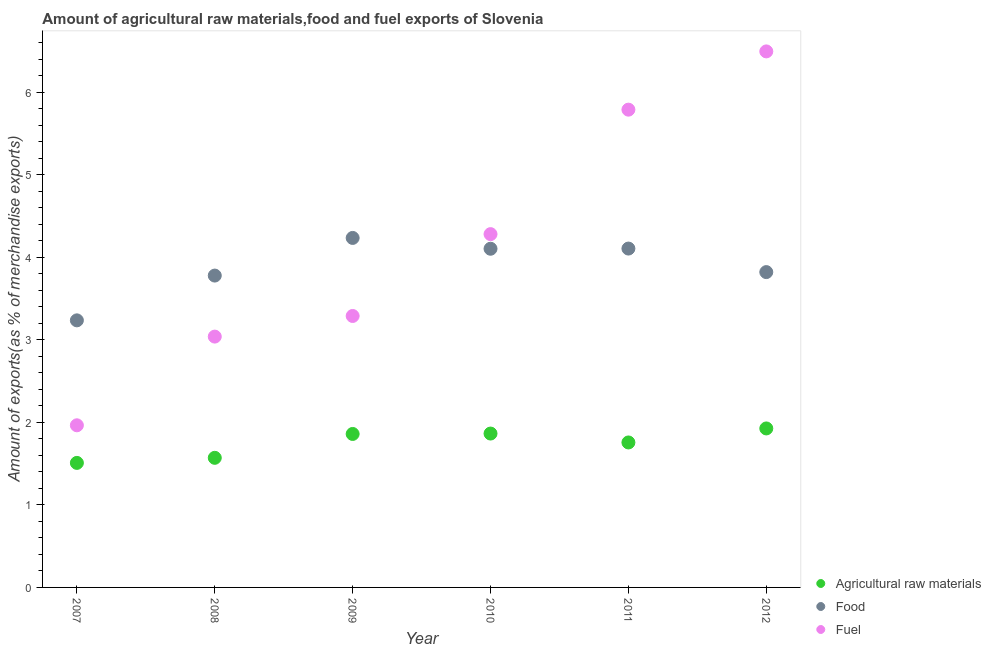What is the percentage of raw materials exports in 2010?
Ensure brevity in your answer.  1.87. Across all years, what is the maximum percentage of fuel exports?
Provide a short and direct response. 6.5. Across all years, what is the minimum percentage of raw materials exports?
Ensure brevity in your answer.  1.51. In which year was the percentage of fuel exports maximum?
Ensure brevity in your answer.  2012. In which year was the percentage of food exports minimum?
Your response must be concise. 2007. What is the total percentage of fuel exports in the graph?
Give a very brief answer. 24.87. What is the difference between the percentage of raw materials exports in 2009 and that in 2012?
Keep it short and to the point. -0.07. What is the difference between the percentage of raw materials exports in 2007 and the percentage of fuel exports in 2010?
Keep it short and to the point. -2.77. What is the average percentage of fuel exports per year?
Provide a succinct answer. 4.14. In the year 2007, what is the difference between the percentage of food exports and percentage of fuel exports?
Your response must be concise. 1.27. In how many years, is the percentage of fuel exports greater than 3.4 %?
Make the answer very short. 3. What is the ratio of the percentage of raw materials exports in 2009 to that in 2012?
Make the answer very short. 0.97. Is the difference between the percentage of fuel exports in 2009 and 2010 greater than the difference between the percentage of raw materials exports in 2009 and 2010?
Provide a succinct answer. No. What is the difference between the highest and the second highest percentage of fuel exports?
Keep it short and to the point. 0.71. What is the difference between the highest and the lowest percentage of food exports?
Give a very brief answer. 1. In how many years, is the percentage of food exports greater than the average percentage of food exports taken over all years?
Your response must be concise. 3. Is the sum of the percentage of raw materials exports in 2007 and 2011 greater than the maximum percentage of fuel exports across all years?
Provide a short and direct response. No. Does the percentage of food exports monotonically increase over the years?
Ensure brevity in your answer.  No. Is the percentage of food exports strictly less than the percentage of fuel exports over the years?
Your answer should be very brief. No. Does the graph contain any zero values?
Ensure brevity in your answer.  No. Does the graph contain grids?
Ensure brevity in your answer.  No. How many legend labels are there?
Your response must be concise. 3. What is the title of the graph?
Your response must be concise. Amount of agricultural raw materials,food and fuel exports of Slovenia. What is the label or title of the X-axis?
Your answer should be very brief. Year. What is the label or title of the Y-axis?
Your response must be concise. Amount of exports(as % of merchandise exports). What is the Amount of exports(as % of merchandise exports) of Agricultural raw materials in 2007?
Make the answer very short. 1.51. What is the Amount of exports(as % of merchandise exports) of Food in 2007?
Provide a short and direct response. 3.24. What is the Amount of exports(as % of merchandise exports) in Fuel in 2007?
Provide a succinct answer. 1.97. What is the Amount of exports(as % of merchandise exports) in Agricultural raw materials in 2008?
Your answer should be compact. 1.57. What is the Amount of exports(as % of merchandise exports) of Food in 2008?
Keep it short and to the point. 3.78. What is the Amount of exports(as % of merchandise exports) of Fuel in 2008?
Keep it short and to the point. 3.04. What is the Amount of exports(as % of merchandise exports) of Agricultural raw materials in 2009?
Your answer should be compact. 1.86. What is the Amount of exports(as % of merchandise exports) in Food in 2009?
Offer a very short reply. 4.24. What is the Amount of exports(as % of merchandise exports) in Fuel in 2009?
Make the answer very short. 3.29. What is the Amount of exports(as % of merchandise exports) of Agricultural raw materials in 2010?
Provide a succinct answer. 1.87. What is the Amount of exports(as % of merchandise exports) in Food in 2010?
Offer a very short reply. 4.11. What is the Amount of exports(as % of merchandise exports) of Fuel in 2010?
Keep it short and to the point. 4.28. What is the Amount of exports(as % of merchandise exports) of Agricultural raw materials in 2011?
Your answer should be very brief. 1.76. What is the Amount of exports(as % of merchandise exports) in Food in 2011?
Give a very brief answer. 4.11. What is the Amount of exports(as % of merchandise exports) of Fuel in 2011?
Give a very brief answer. 5.79. What is the Amount of exports(as % of merchandise exports) in Agricultural raw materials in 2012?
Your answer should be compact. 1.93. What is the Amount of exports(as % of merchandise exports) of Food in 2012?
Offer a terse response. 3.82. What is the Amount of exports(as % of merchandise exports) of Fuel in 2012?
Make the answer very short. 6.5. Across all years, what is the maximum Amount of exports(as % of merchandise exports) in Agricultural raw materials?
Your answer should be compact. 1.93. Across all years, what is the maximum Amount of exports(as % of merchandise exports) of Food?
Provide a short and direct response. 4.24. Across all years, what is the maximum Amount of exports(as % of merchandise exports) of Fuel?
Provide a succinct answer. 6.5. Across all years, what is the minimum Amount of exports(as % of merchandise exports) in Agricultural raw materials?
Give a very brief answer. 1.51. Across all years, what is the minimum Amount of exports(as % of merchandise exports) in Food?
Ensure brevity in your answer.  3.24. Across all years, what is the minimum Amount of exports(as % of merchandise exports) in Fuel?
Offer a terse response. 1.97. What is the total Amount of exports(as % of merchandise exports) of Agricultural raw materials in the graph?
Give a very brief answer. 10.49. What is the total Amount of exports(as % of merchandise exports) in Food in the graph?
Ensure brevity in your answer.  23.29. What is the total Amount of exports(as % of merchandise exports) in Fuel in the graph?
Ensure brevity in your answer.  24.87. What is the difference between the Amount of exports(as % of merchandise exports) in Agricultural raw materials in 2007 and that in 2008?
Your response must be concise. -0.06. What is the difference between the Amount of exports(as % of merchandise exports) of Food in 2007 and that in 2008?
Your answer should be compact. -0.54. What is the difference between the Amount of exports(as % of merchandise exports) in Fuel in 2007 and that in 2008?
Make the answer very short. -1.08. What is the difference between the Amount of exports(as % of merchandise exports) in Agricultural raw materials in 2007 and that in 2009?
Offer a terse response. -0.35. What is the difference between the Amount of exports(as % of merchandise exports) of Food in 2007 and that in 2009?
Make the answer very short. -1. What is the difference between the Amount of exports(as % of merchandise exports) in Fuel in 2007 and that in 2009?
Give a very brief answer. -1.33. What is the difference between the Amount of exports(as % of merchandise exports) of Agricultural raw materials in 2007 and that in 2010?
Offer a terse response. -0.36. What is the difference between the Amount of exports(as % of merchandise exports) of Food in 2007 and that in 2010?
Give a very brief answer. -0.87. What is the difference between the Amount of exports(as % of merchandise exports) of Fuel in 2007 and that in 2010?
Your response must be concise. -2.32. What is the difference between the Amount of exports(as % of merchandise exports) in Agricultural raw materials in 2007 and that in 2011?
Make the answer very short. -0.25. What is the difference between the Amount of exports(as % of merchandise exports) in Food in 2007 and that in 2011?
Provide a succinct answer. -0.87. What is the difference between the Amount of exports(as % of merchandise exports) in Fuel in 2007 and that in 2011?
Offer a terse response. -3.83. What is the difference between the Amount of exports(as % of merchandise exports) of Agricultural raw materials in 2007 and that in 2012?
Make the answer very short. -0.42. What is the difference between the Amount of exports(as % of merchandise exports) of Food in 2007 and that in 2012?
Ensure brevity in your answer.  -0.58. What is the difference between the Amount of exports(as % of merchandise exports) in Fuel in 2007 and that in 2012?
Offer a very short reply. -4.53. What is the difference between the Amount of exports(as % of merchandise exports) of Agricultural raw materials in 2008 and that in 2009?
Provide a succinct answer. -0.29. What is the difference between the Amount of exports(as % of merchandise exports) in Food in 2008 and that in 2009?
Provide a short and direct response. -0.46. What is the difference between the Amount of exports(as % of merchandise exports) of Fuel in 2008 and that in 2009?
Ensure brevity in your answer.  -0.25. What is the difference between the Amount of exports(as % of merchandise exports) in Agricultural raw materials in 2008 and that in 2010?
Give a very brief answer. -0.29. What is the difference between the Amount of exports(as % of merchandise exports) of Food in 2008 and that in 2010?
Offer a very short reply. -0.33. What is the difference between the Amount of exports(as % of merchandise exports) in Fuel in 2008 and that in 2010?
Offer a terse response. -1.24. What is the difference between the Amount of exports(as % of merchandise exports) of Agricultural raw materials in 2008 and that in 2011?
Ensure brevity in your answer.  -0.19. What is the difference between the Amount of exports(as % of merchandise exports) in Food in 2008 and that in 2011?
Your answer should be compact. -0.33. What is the difference between the Amount of exports(as % of merchandise exports) in Fuel in 2008 and that in 2011?
Give a very brief answer. -2.75. What is the difference between the Amount of exports(as % of merchandise exports) in Agricultural raw materials in 2008 and that in 2012?
Your answer should be very brief. -0.36. What is the difference between the Amount of exports(as % of merchandise exports) in Food in 2008 and that in 2012?
Ensure brevity in your answer.  -0.04. What is the difference between the Amount of exports(as % of merchandise exports) in Fuel in 2008 and that in 2012?
Ensure brevity in your answer.  -3.46. What is the difference between the Amount of exports(as % of merchandise exports) in Agricultural raw materials in 2009 and that in 2010?
Ensure brevity in your answer.  -0. What is the difference between the Amount of exports(as % of merchandise exports) in Food in 2009 and that in 2010?
Your answer should be compact. 0.13. What is the difference between the Amount of exports(as % of merchandise exports) of Fuel in 2009 and that in 2010?
Give a very brief answer. -0.99. What is the difference between the Amount of exports(as % of merchandise exports) of Agricultural raw materials in 2009 and that in 2011?
Make the answer very short. 0.1. What is the difference between the Amount of exports(as % of merchandise exports) in Food in 2009 and that in 2011?
Your response must be concise. 0.13. What is the difference between the Amount of exports(as % of merchandise exports) of Fuel in 2009 and that in 2011?
Your answer should be very brief. -2.5. What is the difference between the Amount of exports(as % of merchandise exports) in Agricultural raw materials in 2009 and that in 2012?
Ensure brevity in your answer.  -0.07. What is the difference between the Amount of exports(as % of merchandise exports) in Food in 2009 and that in 2012?
Ensure brevity in your answer.  0.41. What is the difference between the Amount of exports(as % of merchandise exports) of Fuel in 2009 and that in 2012?
Provide a succinct answer. -3.21. What is the difference between the Amount of exports(as % of merchandise exports) in Agricultural raw materials in 2010 and that in 2011?
Give a very brief answer. 0.11. What is the difference between the Amount of exports(as % of merchandise exports) in Food in 2010 and that in 2011?
Ensure brevity in your answer.  -0. What is the difference between the Amount of exports(as % of merchandise exports) in Fuel in 2010 and that in 2011?
Provide a succinct answer. -1.51. What is the difference between the Amount of exports(as % of merchandise exports) in Agricultural raw materials in 2010 and that in 2012?
Keep it short and to the point. -0.06. What is the difference between the Amount of exports(as % of merchandise exports) in Food in 2010 and that in 2012?
Give a very brief answer. 0.28. What is the difference between the Amount of exports(as % of merchandise exports) of Fuel in 2010 and that in 2012?
Your response must be concise. -2.21. What is the difference between the Amount of exports(as % of merchandise exports) of Agricultural raw materials in 2011 and that in 2012?
Your response must be concise. -0.17. What is the difference between the Amount of exports(as % of merchandise exports) of Food in 2011 and that in 2012?
Your response must be concise. 0.29. What is the difference between the Amount of exports(as % of merchandise exports) of Fuel in 2011 and that in 2012?
Make the answer very short. -0.71. What is the difference between the Amount of exports(as % of merchandise exports) in Agricultural raw materials in 2007 and the Amount of exports(as % of merchandise exports) in Food in 2008?
Your answer should be compact. -2.27. What is the difference between the Amount of exports(as % of merchandise exports) of Agricultural raw materials in 2007 and the Amount of exports(as % of merchandise exports) of Fuel in 2008?
Offer a very short reply. -1.53. What is the difference between the Amount of exports(as % of merchandise exports) of Food in 2007 and the Amount of exports(as % of merchandise exports) of Fuel in 2008?
Keep it short and to the point. 0.2. What is the difference between the Amount of exports(as % of merchandise exports) of Agricultural raw materials in 2007 and the Amount of exports(as % of merchandise exports) of Food in 2009?
Provide a succinct answer. -2.73. What is the difference between the Amount of exports(as % of merchandise exports) in Agricultural raw materials in 2007 and the Amount of exports(as % of merchandise exports) in Fuel in 2009?
Make the answer very short. -1.78. What is the difference between the Amount of exports(as % of merchandise exports) in Food in 2007 and the Amount of exports(as % of merchandise exports) in Fuel in 2009?
Give a very brief answer. -0.05. What is the difference between the Amount of exports(as % of merchandise exports) in Agricultural raw materials in 2007 and the Amount of exports(as % of merchandise exports) in Food in 2010?
Provide a short and direct response. -2.6. What is the difference between the Amount of exports(as % of merchandise exports) in Agricultural raw materials in 2007 and the Amount of exports(as % of merchandise exports) in Fuel in 2010?
Keep it short and to the point. -2.77. What is the difference between the Amount of exports(as % of merchandise exports) of Food in 2007 and the Amount of exports(as % of merchandise exports) of Fuel in 2010?
Provide a succinct answer. -1.05. What is the difference between the Amount of exports(as % of merchandise exports) in Agricultural raw materials in 2007 and the Amount of exports(as % of merchandise exports) in Food in 2011?
Your answer should be very brief. -2.6. What is the difference between the Amount of exports(as % of merchandise exports) in Agricultural raw materials in 2007 and the Amount of exports(as % of merchandise exports) in Fuel in 2011?
Your answer should be compact. -4.28. What is the difference between the Amount of exports(as % of merchandise exports) of Food in 2007 and the Amount of exports(as % of merchandise exports) of Fuel in 2011?
Your answer should be very brief. -2.55. What is the difference between the Amount of exports(as % of merchandise exports) in Agricultural raw materials in 2007 and the Amount of exports(as % of merchandise exports) in Food in 2012?
Keep it short and to the point. -2.31. What is the difference between the Amount of exports(as % of merchandise exports) of Agricultural raw materials in 2007 and the Amount of exports(as % of merchandise exports) of Fuel in 2012?
Offer a terse response. -4.99. What is the difference between the Amount of exports(as % of merchandise exports) of Food in 2007 and the Amount of exports(as % of merchandise exports) of Fuel in 2012?
Your answer should be compact. -3.26. What is the difference between the Amount of exports(as % of merchandise exports) of Agricultural raw materials in 2008 and the Amount of exports(as % of merchandise exports) of Food in 2009?
Make the answer very short. -2.67. What is the difference between the Amount of exports(as % of merchandise exports) of Agricultural raw materials in 2008 and the Amount of exports(as % of merchandise exports) of Fuel in 2009?
Ensure brevity in your answer.  -1.72. What is the difference between the Amount of exports(as % of merchandise exports) of Food in 2008 and the Amount of exports(as % of merchandise exports) of Fuel in 2009?
Your response must be concise. 0.49. What is the difference between the Amount of exports(as % of merchandise exports) of Agricultural raw materials in 2008 and the Amount of exports(as % of merchandise exports) of Food in 2010?
Offer a terse response. -2.53. What is the difference between the Amount of exports(as % of merchandise exports) in Agricultural raw materials in 2008 and the Amount of exports(as % of merchandise exports) in Fuel in 2010?
Your response must be concise. -2.71. What is the difference between the Amount of exports(as % of merchandise exports) of Food in 2008 and the Amount of exports(as % of merchandise exports) of Fuel in 2010?
Make the answer very short. -0.5. What is the difference between the Amount of exports(as % of merchandise exports) in Agricultural raw materials in 2008 and the Amount of exports(as % of merchandise exports) in Food in 2011?
Your answer should be very brief. -2.54. What is the difference between the Amount of exports(as % of merchandise exports) in Agricultural raw materials in 2008 and the Amount of exports(as % of merchandise exports) in Fuel in 2011?
Offer a terse response. -4.22. What is the difference between the Amount of exports(as % of merchandise exports) of Food in 2008 and the Amount of exports(as % of merchandise exports) of Fuel in 2011?
Give a very brief answer. -2.01. What is the difference between the Amount of exports(as % of merchandise exports) in Agricultural raw materials in 2008 and the Amount of exports(as % of merchandise exports) in Food in 2012?
Give a very brief answer. -2.25. What is the difference between the Amount of exports(as % of merchandise exports) of Agricultural raw materials in 2008 and the Amount of exports(as % of merchandise exports) of Fuel in 2012?
Your response must be concise. -4.93. What is the difference between the Amount of exports(as % of merchandise exports) of Food in 2008 and the Amount of exports(as % of merchandise exports) of Fuel in 2012?
Keep it short and to the point. -2.72. What is the difference between the Amount of exports(as % of merchandise exports) of Agricultural raw materials in 2009 and the Amount of exports(as % of merchandise exports) of Food in 2010?
Provide a short and direct response. -2.25. What is the difference between the Amount of exports(as % of merchandise exports) in Agricultural raw materials in 2009 and the Amount of exports(as % of merchandise exports) in Fuel in 2010?
Your answer should be compact. -2.42. What is the difference between the Amount of exports(as % of merchandise exports) of Food in 2009 and the Amount of exports(as % of merchandise exports) of Fuel in 2010?
Give a very brief answer. -0.05. What is the difference between the Amount of exports(as % of merchandise exports) of Agricultural raw materials in 2009 and the Amount of exports(as % of merchandise exports) of Food in 2011?
Your answer should be compact. -2.25. What is the difference between the Amount of exports(as % of merchandise exports) in Agricultural raw materials in 2009 and the Amount of exports(as % of merchandise exports) in Fuel in 2011?
Give a very brief answer. -3.93. What is the difference between the Amount of exports(as % of merchandise exports) in Food in 2009 and the Amount of exports(as % of merchandise exports) in Fuel in 2011?
Provide a short and direct response. -1.55. What is the difference between the Amount of exports(as % of merchandise exports) of Agricultural raw materials in 2009 and the Amount of exports(as % of merchandise exports) of Food in 2012?
Offer a very short reply. -1.96. What is the difference between the Amount of exports(as % of merchandise exports) of Agricultural raw materials in 2009 and the Amount of exports(as % of merchandise exports) of Fuel in 2012?
Your answer should be compact. -4.64. What is the difference between the Amount of exports(as % of merchandise exports) in Food in 2009 and the Amount of exports(as % of merchandise exports) in Fuel in 2012?
Your response must be concise. -2.26. What is the difference between the Amount of exports(as % of merchandise exports) in Agricultural raw materials in 2010 and the Amount of exports(as % of merchandise exports) in Food in 2011?
Offer a very short reply. -2.24. What is the difference between the Amount of exports(as % of merchandise exports) in Agricultural raw materials in 2010 and the Amount of exports(as % of merchandise exports) in Fuel in 2011?
Keep it short and to the point. -3.93. What is the difference between the Amount of exports(as % of merchandise exports) in Food in 2010 and the Amount of exports(as % of merchandise exports) in Fuel in 2011?
Your response must be concise. -1.69. What is the difference between the Amount of exports(as % of merchandise exports) in Agricultural raw materials in 2010 and the Amount of exports(as % of merchandise exports) in Food in 2012?
Keep it short and to the point. -1.96. What is the difference between the Amount of exports(as % of merchandise exports) of Agricultural raw materials in 2010 and the Amount of exports(as % of merchandise exports) of Fuel in 2012?
Your answer should be very brief. -4.63. What is the difference between the Amount of exports(as % of merchandise exports) of Food in 2010 and the Amount of exports(as % of merchandise exports) of Fuel in 2012?
Ensure brevity in your answer.  -2.39. What is the difference between the Amount of exports(as % of merchandise exports) in Agricultural raw materials in 2011 and the Amount of exports(as % of merchandise exports) in Food in 2012?
Make the answer very short. -2.06. What is the difference between the Amount of exports(as % of merchandise exports) of Agricultural raw materials in 2011 and the Amount of exports(as % of merchandise exports) of Fuel in 2012?
Your answer should be very brief. -4.74. What is the difference between the Amount of exports(as % of merchandise exports) in Food in 2011 and the Amount of exports(as % of merchandise exports) in Fuel in 2012?
Provide a short and direct response. -2.39. What is the average Amount of exports(as % of merchandise exports) of Agricultural raw materials per year?
Provide a short and direct response. 1.75. What is the average Amount of exports(as % of merchandise exports) of Food per year?
Offer a very short reply. 3.88. What is the average Amount of exports(as % of merchandise exports) of Fuel per year?
Your response must be concise. 4.14. In the year 2007, what is the difference between the Amount of exports(as % of merchandise exports) of Agricultural raw materials and Amount of exports(as % of merchandise exports) of Food?
Keep it short and to the point. -1.73. In the year 2007, what is the difference between the Amount of exports(as % of merchandise exports) of Agricultural raw materials and Amount of exports(as % of merchandise exports) of Fuel?
Keep it short and to the point. -0.46. In the year 2007, what is the difference between the Amount of exports(as % of merchandise exports) of Food and Amount of exports(as % of merchandise exports) of Fuel?
Offer a terse response. 1.27. In the year 2008, what is the difference between the Amount of exports(as % of merchandise exports) of Agricultural raw materials and Amount of exports(as % of merchandise exports) of Food?
Ensure brevity in your answer.  -2.21. In the year 2008, what is the difference between the Amount of exports(as % of merchandise exports) in Agricultural raw materials and Amount of exports(as % of merchandise exports) in Fuel?
Provide a succinct answer. -1.47. In the year 2008, what is the difference between the Amount of exports(as % of merchandise exports) of Food and Amount of exports(as % of merchandise exports) of Fuel?
Give a very brief answer. 0.74. In the year 2009, what is the difference between the Amount of exports(as % of merchandise exports) of Agricultural raw materials and Amount of exports(as % of merchandise exports) of Food?
Ensure brevity in your answer.  -2.38. In the year 2009, what is the difference between the Amount of exports(as % of merchandise exports) in Agricultural raw materials and Amount of exports(as % of merchandise exports) in Fuel?
Offer a terse response. -1.43. In the year 2009, what is the difference between the Amount of exports(as % of merchandise exports) of Food and Amount of exports(as % of merchandise exports) of Fuel?
Offer a terse response. 0.95. In the year 2010, what is the difference between the Amount of exports(as % of merchandise exports) in Agricultural raw materials and Amount of exports(as % of merchandise exports) in Food?
Ensure brevity in your answer.  -2.24. In the year 2010, what is the difference between the Amount of exports(as % of merchandise exports) in Agricultural raw materials and Amount of exports(as % of merchandise exports) in Fuel?
Your answer should be compact. -2.42. In the year 2010, what is the difference between the Amount of exports(as % of merchandise exports) of Food and Amount of exports(as % of merchandise exports) of Fuel?
Make the answer very short. -0.18. In the year 2011, what is the difference between the Amount of exports(as % of merchandise exports) of Agricultural raw materials and Amount of exports(as % of merchandise exports) of Food?
Keep it short and to the point. -2.35. In the year 2011, what is the difference between the Amount of exports(as % of merchandise exports) in Agricultural raw materials and Amount of exports(as % of merchandise exports) in Fuel?
Provide a short and direct response. -4.03. In the year 2011, what is the difference between the Amount of exports(as % of merchandise exports) of Food and Amount of exports(as % of merchandise exports) of Fuel?
Make the answer very short. -1.68. In the year 2012, what is the difference between the Amount of exports(as % of merchandise exports) of Agricultural raw materials and Amount of exports(as % of merchandise exports) of Food?
Give a very brief answer. -1.9. In the year 2012, what is the difference between the Amount of exports(as % of merchandise exports) in Agricultural raw materials and Amount of exports(as % of merchandise exports) in Fuel?
Your answer should be very brief. -4.57. In the year 2012, what is the difference between the Amount of exports(as % of merchandise exports) in Food and Amount of exports(as % of merchandise exports) in Fuel?
Your answer should be very brief. -2.68. What is the ratio of the Amount of exports(as % of merchandise exports) in Agricultural raw materials in 2007 to that in 2008?
Offer a terse response. 0.96. What is the ratio of the Amount of exports(as % of merchandise exports) in Food in 2007 to that in 2008?
Provide a succinct answer. 0.86. What is the ratio of the Amount of exports(as % of merchandise exports) in Fuel in 2007 to that in 2008?
Provide a succinct answer. 0.65. What is the ratio of the Amount of exports(as % of merchandise exports) in Agricultural raw materials in 2007 to that in 2009?
Make the answer very short. 0.81. What is the ratio of the Amount of exports(as % of merchandise exports) of Food in 2007 to that in 2009?
Provide a short and direct response. 0.76. What is the ratio of the Amount of exports(as % of merchandise exports) of Fuel in 2007 to that in 2009?
Your answer should be very brief. 0.6. What is the ratio of the Amount of exports(as % of merchandise exports) in Agricultural raw materials in 2007 to that in 2010?
Ensure brevity in your answer.  0.81. What is the ratio of the Amount of exports(as % of merchandise exports) of Food in 2007 to that in 2010?
Ensure brevity in your answer.  0.79. What is the ratio of the Amount of exports(as % of merchandise exports) in Fuel in 2007 to that in 2010?
Give a very brief answer. 0.46. What is the ratio of the Amount of exports(as % of merchandise exports) in Agricultural raw materials in 2007 to that in 2011?
Your response must be concise. 0.86. What is the ratio of the Amount of exports(as % of merchandise exports) in Food in 2007 to that in 2011?
Provide a short and direct response. 0.79. What is the ratio of the Amount of exports(as % of merchandise exports) of Fuel in 2007 to that in 2011?
Offer a very short reply. 0.34. What is the ratio of the Amount of exports(as % of merchandise exports) in Agricultural raw materials in 2007 to that in 2012?
Your answer should be compact. 0.78. What is the ratio of the Amount of exports(as % of merchandise exports) in Food in 2007 to that in 2012?
Ensure brevity in your answer.  0.85. What is the ratio of the Amount of exports(as % of merchandise exports) of Fuel in 2007 to that in 2012?
Ensure brevity in your answer.  0.3. What is the ratio of the Amount of exports(as % of merchandise exports) in Agricultural raw materials in 2008 to that in 2009?
Ensure brevity in your answer.  0.84. What is the ratio of the Amount of exports(as % of merchandise exports) in Food in 2008 to that in 2009?
Give a very brief answer. 0.89. What is the ratio of the Amount of exports(as % of merchandise exports) in Fuel in 2008 to that in 2009?
Make the answer very short. 0.92. What is the ratio of the Amount of exports(as % of merchandise exports) in Agricultural raw materials in 2008 to that in 2010?
Your answer should be compact. 0.84. What is the ratio of the Amount of exports(as % of merchandise exports) of Food in 2008 to that in 2010?
Provide a short and direct response. 0.92. What is the ratio of the Amount of exports(as % of merchandise exports) of Fuel in 2008 to that in 2010?
Give a very brief answer. 0.71. What is the ratio of the Amount of exports(as % of merchandise exports) of Agricultural raw materials in 2008 to that in 2011?
Provide a short and direct response. 0.89. What is the ratio of the Amount of exports(as % of merchandise exports) in Food in 2008 to that in 2011?
Ensure brevity in your answer.  0.92. What is the ratio of the Amount of exports(as % of merchandise exports) of Fuel in 2008 to that in 2011?
Provide a short and direct response. 0.53. What is the ratio of the Amount of exports(as % of merchandise exports) in Agricultural raw materials in 2008 to that in 2012?
Provide a succinct answer. 0.82. What is the ratio of the Amount of exports(as % of merchandise exports) in Fuel in 2008 to that in 2012?
Provide a succinct answer. 0.47. What is the ratio of the Amount of exports(as % of merchandise exports) in Food in 2009 to that in 2010?
Offer a terse response. 1.03. What is the ratio of the Amount of exports(as % of merchandise exports) in Fuel in 2009 to that in 2010?
Your answer should be very brief. 0.77. What is the ratio of the Amount of exports(as % of merchandise exports) of Agricultural raw materials in 2009 to that in 2011?
Offer a very short reply. 1.06. What is the ratio of the Amount of exports(as % of merchandise exports) of Food in 2009 to that in 2011?
Offer a terse response. 1.03. What is the ratio of the Amount of exports(as % of merchandise exports) in Fuel in 2009 to that in 2011?
Give a very brief answer. 0.57. What is the ratio of the Amount of exports(as % of merchandise exports) of Agricultural raw materials in 2009 to that in 2012?
Offer a terse response. 0.97. What is the ratio of the Amount of exports(as % of merchandise exports) in Food in 2009 to that in 2012?
Your answer should be compact. 1.11. What is the ratio of the Amount of exports(as % of merchandise exports) in Fuel in 2009 to that in 2012?
Ensure brevity in your answer.  0.51. What is the ratio of the Amount of exports(as % of merchandise exports) in Agricultural raw materials in 2010 to that in 2011?
Offer a terse response. 1.06. What is the ratio of the Amount of exports(as % of merchandise exports) in Fuel in 2010 to that in 2011?
Offer a very short reply. 0.74. What is the ratio of the Amount of exports(as % of merchandise exports) of Agricultural raw materials in 2010 to that in 2012?
Ensure brevity in your answer.  0.97. What is the ratio of the Amount of exports(as % of merchandise exports) in Food in 2010 to that in 2012?
Keep it short and to the point. 1.07. What is the ratio of the Amount of exports(as % of merchandise exports) of Fuel in 2010 to that in 2012?
Your answer should be compact. 0.66. What is the ratio of the Amount of exports(as % of merchandise exports) in Agricultural raw materials in 2011 to that in 2012?
Your answer should be very brief. 0.91. What is the ratio of the Amount of exports(as % of merchandise exports) of Food in 2011 to that in 2012?
Make the answer very short. 1.07. What is the ratio of the Amount of exports(as % of merchandise exports) of Fuel in 2011 to that in 2012?
Provide a succinct answer. 0.89. What is the difference between the highest and the second highest Amount of exports(as % of merchandise exports) in Agricultural raw materials?
Keep it short and to the point. 0.06. What is the difference between the highest and the second highest Amount of exports(as % of merchandise exports) in Food?
Your answer should be compact. 0.13. What is the difference between the highest and the second highest Amount of exports(as % of merchandise exports) in Fuel?
Your answer should be very brief. 0.71. What is the difference between the highest and the lowest Amount of exports(as % of merchandise exports) of Agricultural raw materials?
Make the answer very short. 0.42. What is the difference between the highest and the lowest Amount of exports(as % of merchandise exports) of Fuel?
Provide a short and direct response. 4.53. 